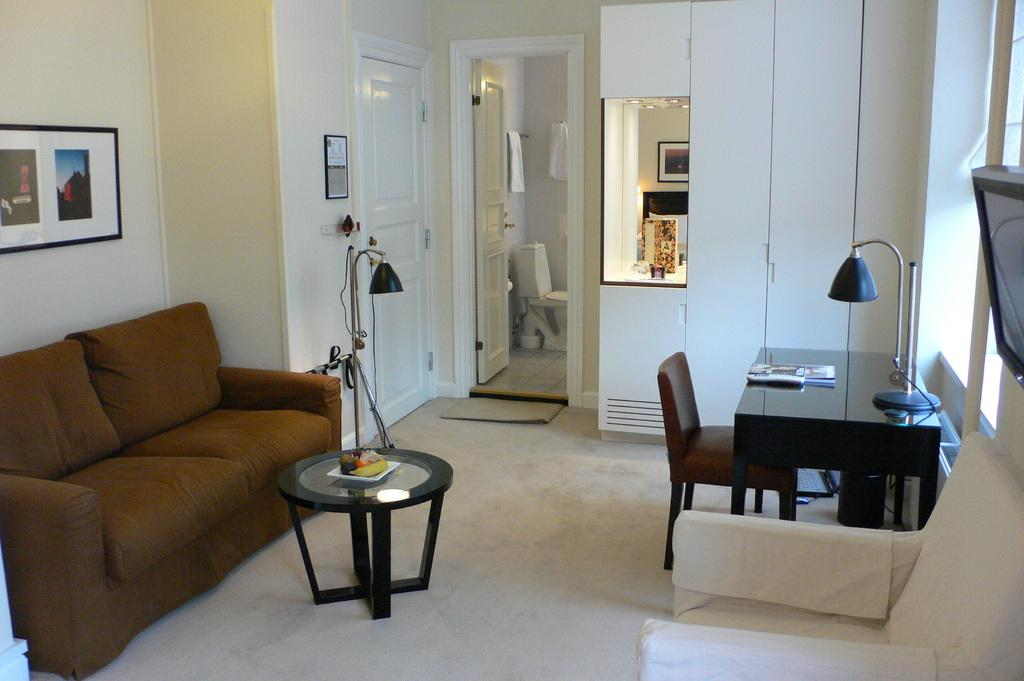What type of furniture is located on the left side of the image? There is a sofa on the left side of the image. What other piece of furniture can be seen in the image? There is a table in the image. Are there any other seating options besides the sofa? Yes, there is a chair in the image. What type of lighting is present in the image? There is a lamp in the image. Can you describe the entrance in the image? There is a door in the image. What type of background is visible in the image? There is a wall in the image. Are there any decorative items on the wall? Yes, there are photo frames in the image. How many buns are on the table in the image? There are no buns present in the image. How many passengers are visible in the image? There are no passengers visible in the image. 